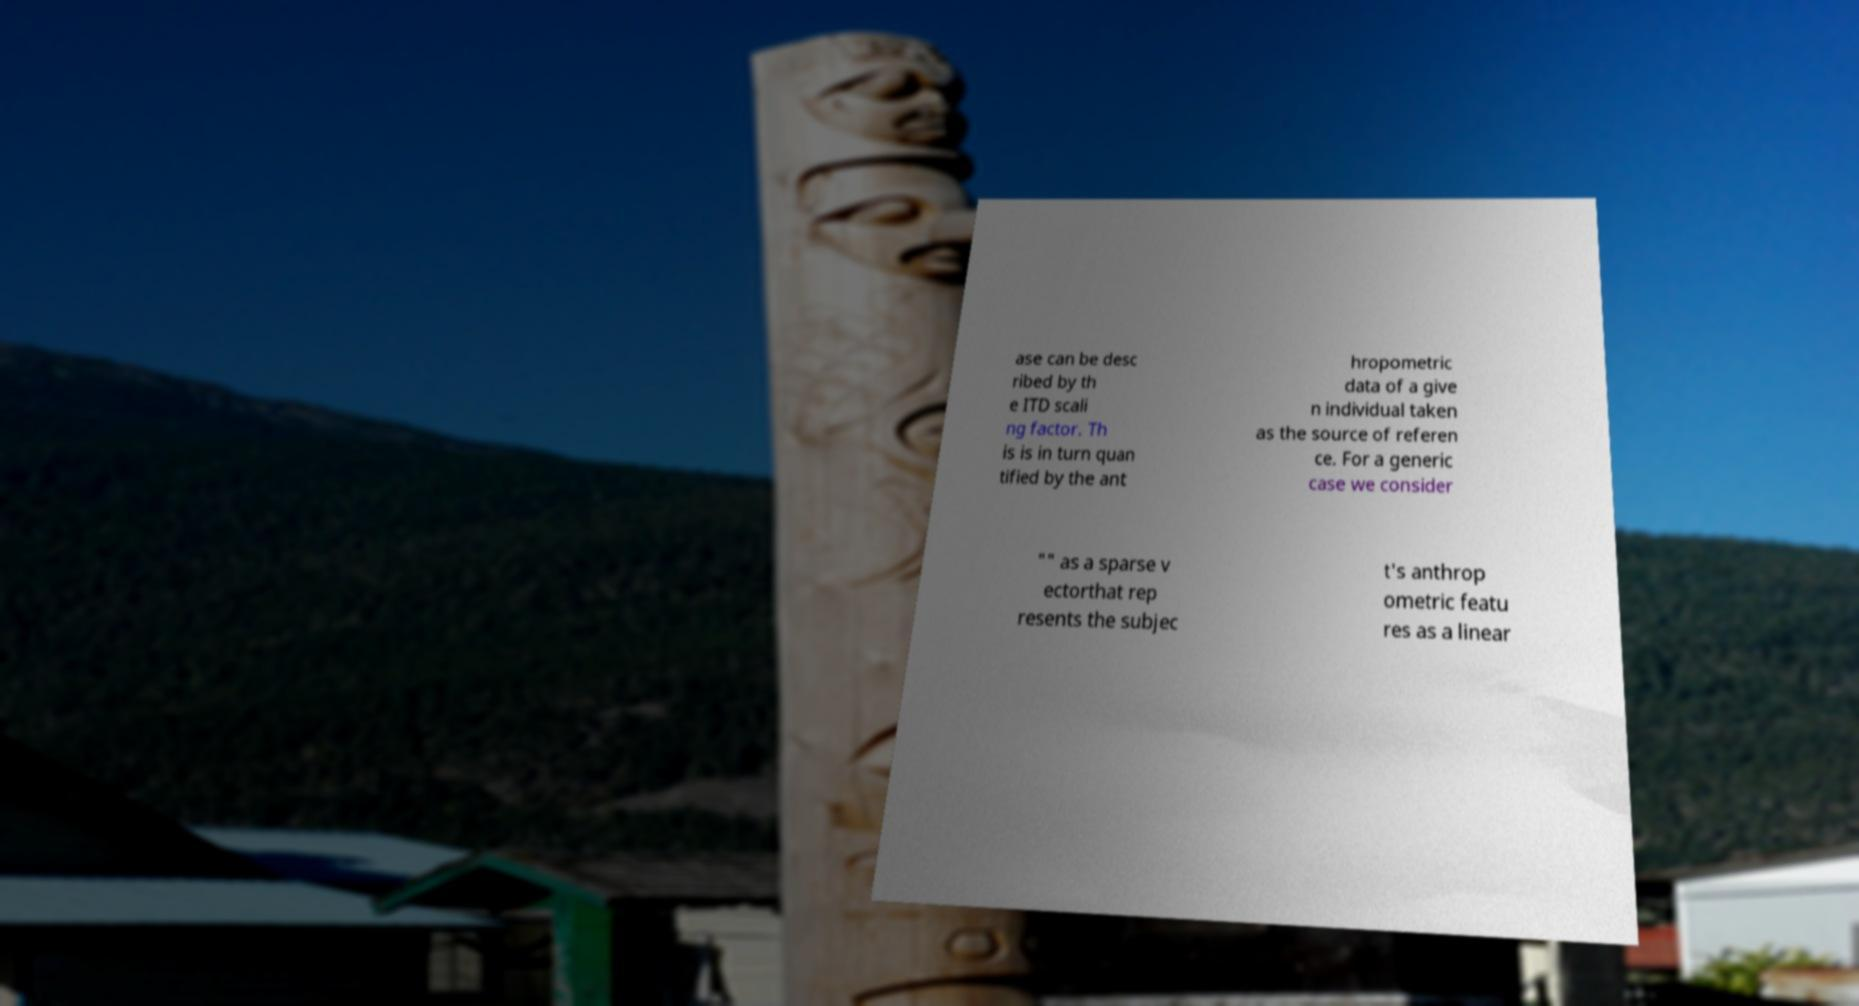For documentation purposes, I need the text within this image transcribed. Could you provide that? ase can be desc ribed by th e ITD scali ng factor. Th is is in turn quan tified by the ant hropometric data of a give n individual taken as the source of referen ce. For a generic case we consider "" as a sparse v ectorthat rep resents the subjec t's anthrop ometric featu res as a linear 